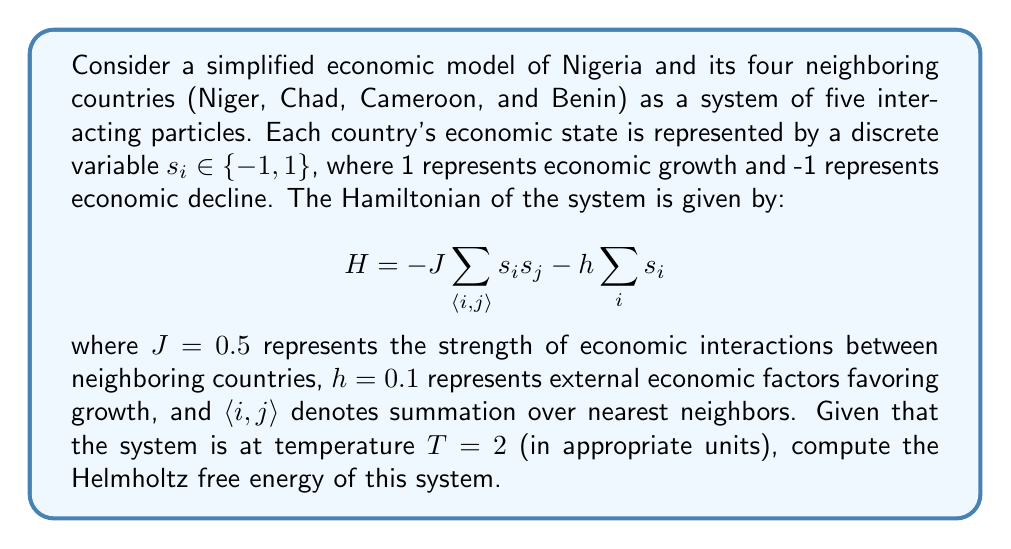Give your solution to this math problem. To solve this problem, we'll follow these steps:

1) First, recall that the Helmholtz free energy $F$ is given by:

   $$ F = -kT \ln Z $$

   where $k$ is Boltzmann's constant (which we'll take as 1 for simplicity), $T$ is the temperature, and $Z$ is the partition function.

2) The partition function $Z$ is given by:

   $$ Z = \sum_{\{s_i\}} e^{-\beta H} $$

   where $\beta = \frac{1}{kT} = \frac{1}{2}$ in this case, and the sum is over all possible configurations of the system.

3) For a system of 5 particles with 2 possible states each, there are $2^5 = 32$ possible configurations.

4) To calculate $Z$, we need to sum $e^{-\beta H}$ for all these configurations. This is computationally intensive, so we'll use a simplification.

5) In mean-field theory, we can approximate the partition function as:

   $$ Z \approx (2 \cosh(\beta(4J\langle s \rangle + h)))^5 $$

   where $\langle s \rangle$ is the average spin, which satisfies the self-consistency equation:

   $$ \langle s \rangle = \tanh(\beta(4J\langle s \rangle + h)) $$

6) Solving this equation numerically (e.g., using Newton's method), we get $\langle s \rangle \approx 0.1986$.

7) Now we can calculate $Z$:

   $$ Z \approx (2 \cosh(0.5(4 * 0.5 * 0.1986 + 0.1)))^5 \approx 41.8739 $$

8) Finally, we can compute the free energy:

   $$ F = -kT \ln Z = -2 \ln(41.8739) \approx -7.4642 $$
Answer: $F \approx -7.4642$ (in appropriate energy units) 